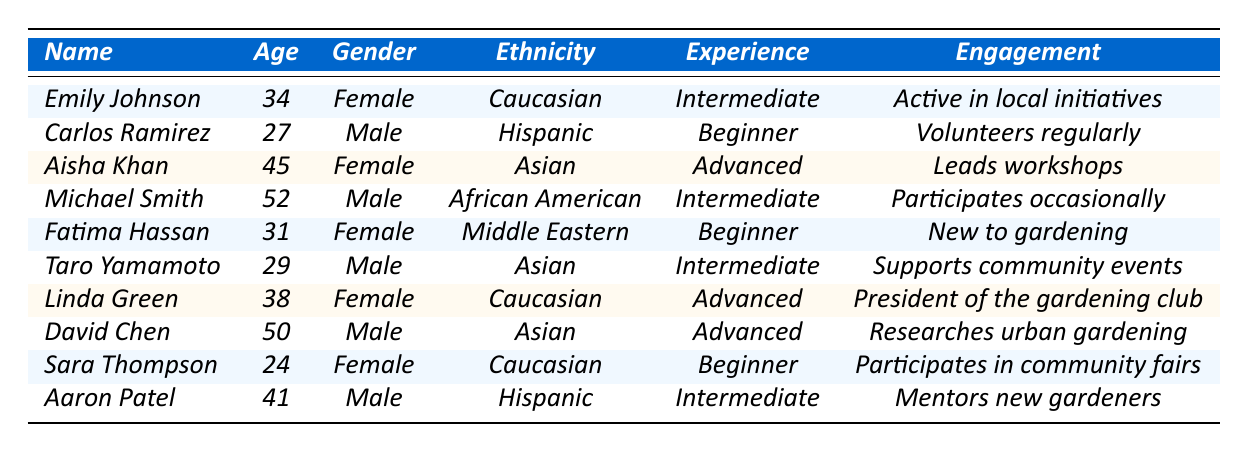What is the age of Emily Johnson? The table shows that Emily Johnson is listed with an age of 34.
Answer: 34 How many participants are at an advanced experience level? There are four participants categorized as having an advanced experience level: Aisha Khan, Linda Green, and David Chen.
Answer: 3 What is the engagement type of Aaron Patel? According to the table, Aaron Patel is listed as "Mentors new gardeners."
Answer: Mentors new gardeners Which city has the youngest participant? The youngest participant is Sara Thompson, who is 24 years old, and she is located in Miami.
Answer: Miami Is there a participant who identifies as Middle Eastern? Yes, Fatima Hassan identifies as Middle Eastern, which is confirmed in the table.
Answer: Yes How many female participants are there in total? To find the number of female participants, I count Emily Johnson, Aisha Khan, Fatima Hassan, Linda Green, and Sara Thompson, which totals to five.
Answer: 5 What age range do the participants fall into? The ages of the participants range from 24 (Sara Thompson) to 52 (Michael Smith).
Answer: 24 to 52 List the experience level of the participant from Houston. David Chen, who is from Houston, has an advanced experience level according to the table.
Answer: Advanced Which ethnic group has the most representatives in the table? The Caucasian ethnicity appears three times: Emily Johnson, Linda Green, and Sara Thompson, making it the most represented group.
Answer: Caucasian Is there a participant who is both male and has an intermediate experience level? Yes, both Michael Smith and Aaron Patel are male participants with an intermediate experience level.
Answer: Yes What is the average age of the participants? To calculate the average age, I sum all the ages (34 + 27 + 45 + 52 + 31 + 29 + 38 + 50 + 24 + 41 =  371) and divide by the number of participants (10), resulting in an average age of 37.1.
Answer: 37.1 